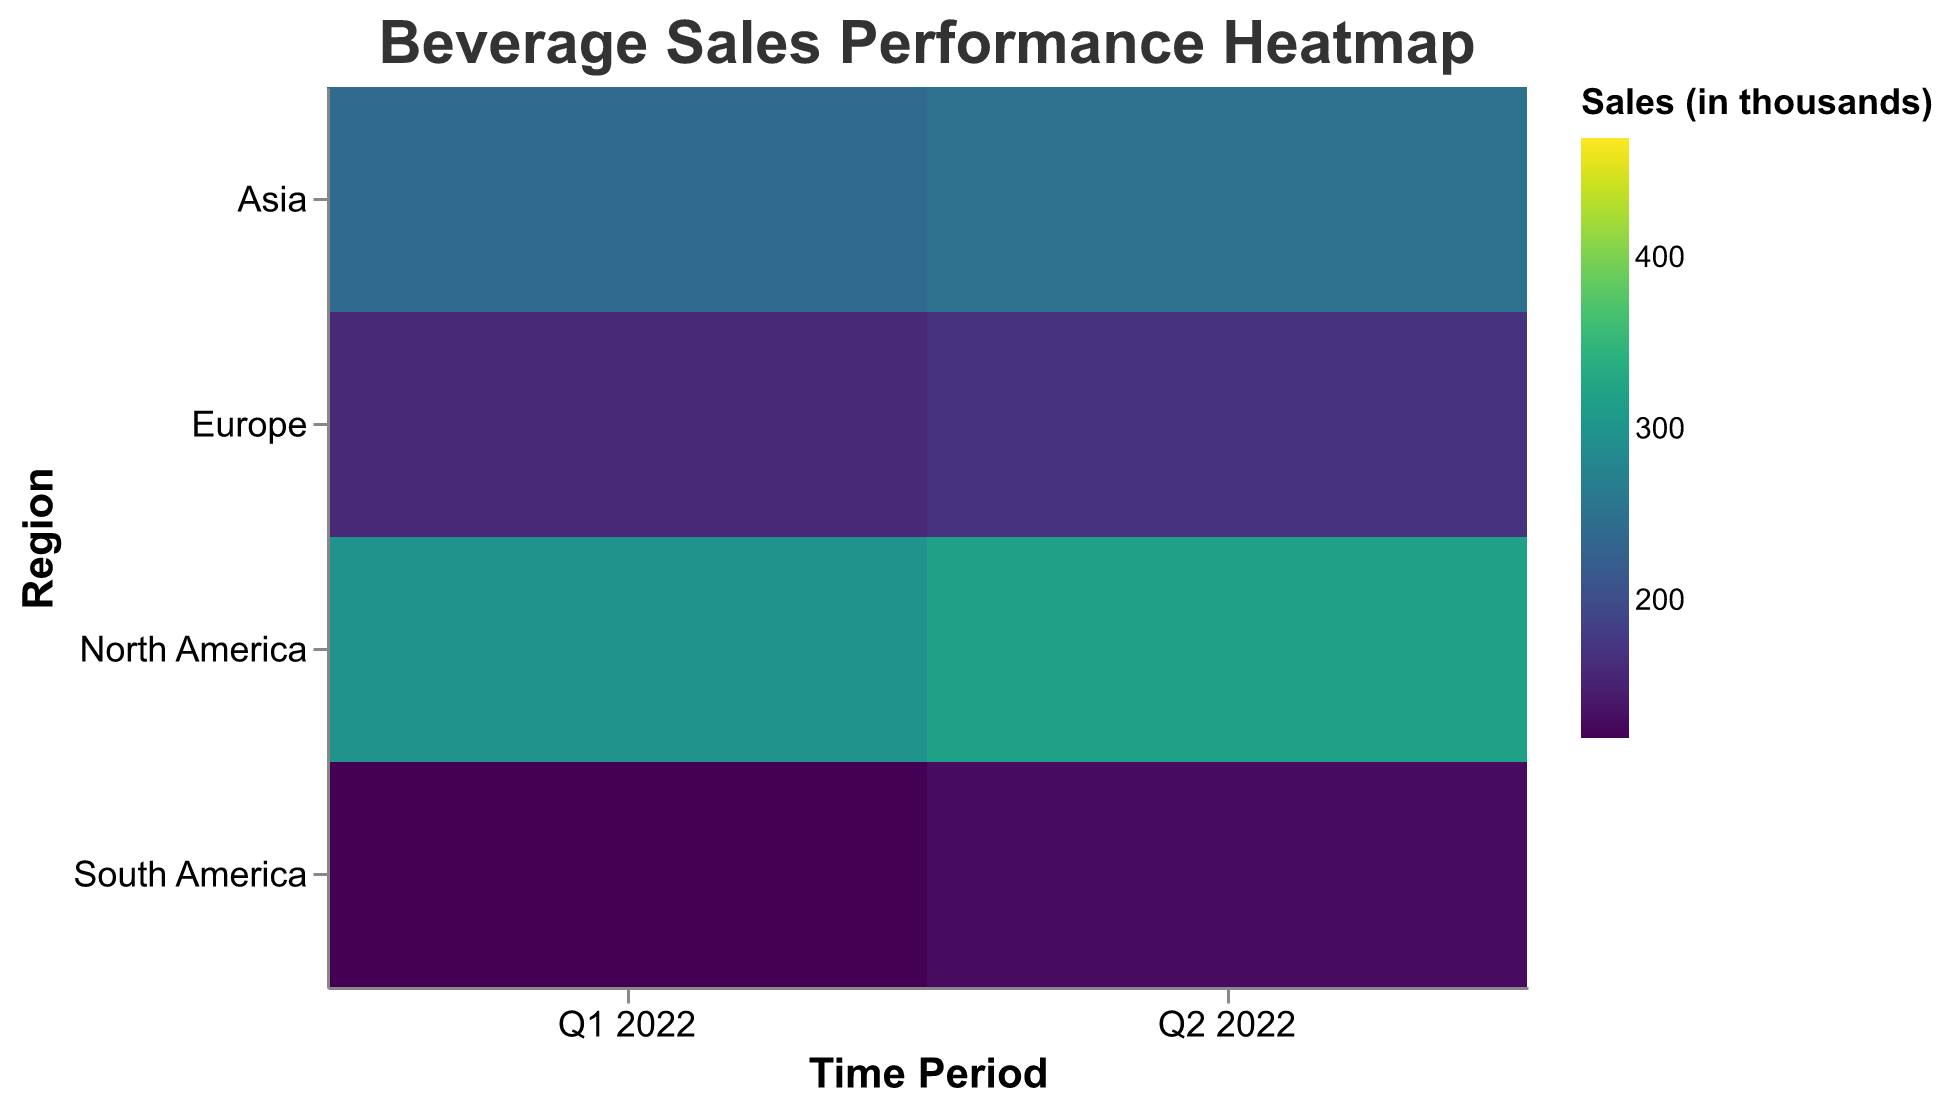What's the highest sales figure for any beverage brand in North America during Q1 2022? Look for the highest value in the heatmap specific to North America in Q1 2022 across all brands. The value is 450 for Coca Cola.
Answer: 450 Which region had the lowest sales for Red Bull in Q2 2022? Compare the sales figures for Red Bull in Q2 2022 across all regions. South America had the lowest figure at 140.
Answer: South America What's the total sales for Coca Cola across all regions in Q1 2022? Sum the sales figures for Coca Cola in Q1 2022 across North America, Europe, Asia, and South America. The values are 450 + 220 + 300 + 150, which sums up to 1120.
Answer: 1120 How does the sales performance of Pepsi in Asia during Q1 2022 compare to Q2 2022? Compare the sales figures for Pepsi in Asia for Q1 2022 and Q2 2022. The values are 280 and 290 respectively, showing an increase by 10 in Q2 2022.
Answer: Increased by 10 Which beverage brand had the most increase in sales from Q1 2022 to Q2 2022 in North America? Calculate the difference in sales figures for each beverage brand in North America between Q1 2022 and Q2 2022, then find the brand with the largest positive difference. Coca Cola increased by 20.
Answer: Coca Cola What’s the average sales for Monster across all regions in Q1 2022? Find the sales figures for Monster in Q1 2022 across all regions (300, 160, 240, 120) and calculate the average: (300 + 160 + 240 + 120) / 4 = 205.
Answer: 205 In which region did Pepsi show the highest increase in sales between Q1 2022 and Q2 2022? Compare the differences in sales for Pepsi between Q1 2022 and Q2 2022 across all regions. North America's increase is 30, Europe’s is 10, Asia’s is 10, and South America's is 10. North America shows the highest increase with 30.
Answer: North America Which brand had consistent sales either increasing or decreasing across all regions from Q1 to Q2 2022? Check if any brand shows either an increase or decrease across all four regions between Q1 2022 and Q2 2022. Coca Cola shows consistent increase across all regions.
Answer: Coca Cola For Q1 2022, how do the sales of Red Bull in Europe compare to Monster in Europe? Look at the heatmap values for Red Bull and Monster in Europe for Q1 2022. Red Bull has 180, and Monster has 160, meaning Red Bull outperformed Monster by 20.
Answer: Red Bull outperformed Monster by 20 